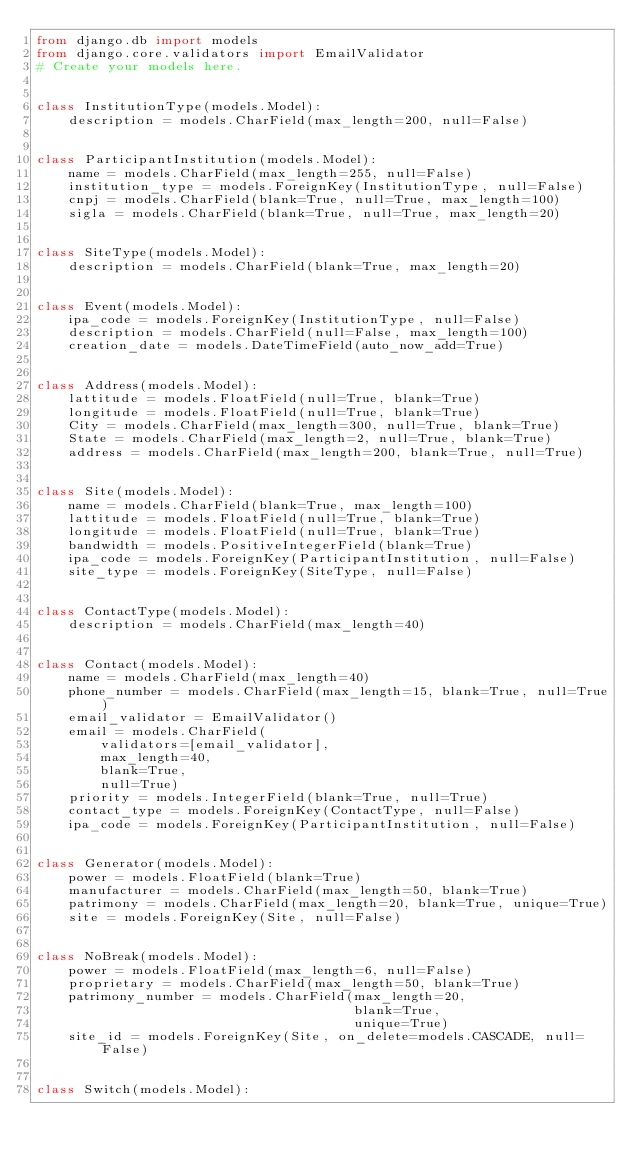Convert code to text. <code><loc_0><loc_0><loc_500><loc_500><_Python_>from django.db import models
from django.core.validators import EmailValidator
# Create your models here.


class InstitutionType(models.Model):
    description = models.CharField(max_length=200, null=False)


class ParticipantInstitution(models.Model):
    name = models.CharField(max_length=255, null=False)
    institution_type = models.ForeignKey(InstitutionType, null=False)
    cnpj = models.CharField(blank=True, null=True, max_length=100)
    sigla = models.CharField(blank=True, null=True, max_length=20)


class SiteType(models.Model):
    description = models.CharField(blank=True, max_length=20)


class Event(models.Model):
    ipa_code = models.ForeignKey(InstitutionType, null=False)
    description = models.CharField(null=False, max_length=100)
    creation_date = models.DateTimeField(auto_now_add=True)


class Address(models.Model):
    lattitude = models.FloatField(null=True, blank=True)
    longitude = models.FloatField(null=True, blank=True)
    City = models.CharField(max_length=300, null=True, blank=True)
    State = models.CharField(max_length=2, null=True, blank=True)
    address = models.CharField(max_length=200, blank=True, null=True)


class Site(models.Model):
    name = models.CharField(blank=True, max_length=100)
    lattitude = models.FloatField(null=True, blank=True)
    longitude = models.FloatField(null=True, blank=True)
    bandwidth = models.PositiveIntegerField(blank=True)
    ipa_code = models.ForeignKey(ParticipantInstitution, null=False)
    site_type = models.ForeignKey(SiteType, null=False)


class ContactType(models.Model):
    description = models.CharField(max_length=40)


class Contact(models.Model):
    name = models.CharField(max_length=40)
    phone_number = models.CharField(max_length=15, blank=True, null=True)
    email_validator = EmailValidator()
    email = models.CharField(
        validators=[email_validator],
        max_length=40,
        blank=True,
        null=True)
    priority = models.IntegerField(blank=True, null=True)
    contact_type = models.ForeignKey(ContactType, null=False)
    ipa_code = models.ForeignKey(ParticipantInstitution, null=False)


class Generator(models.Model):
    power = models.FloatField(blank=True)
    manufacturer = models.CharField(max_length=50, blank=True)
    patrimony = models.CharField(max_length=20, blank=True, unique=True)
    site = models.ForeignKey(Site, null=False)


class NoBreak(models.Model):
    power = models.FloatField(max_length=6, null=False)
    proprietary = models.CharField(max_length=50, blank=True)
    patrimony_number = models.CharField(max_length=20,
                                        blank=True,
                                        unique=True)
    site_id = models.ForeignKey(Site, on_delete=models.CASCADE, null=False)


class Switch(models.Model):</code> 